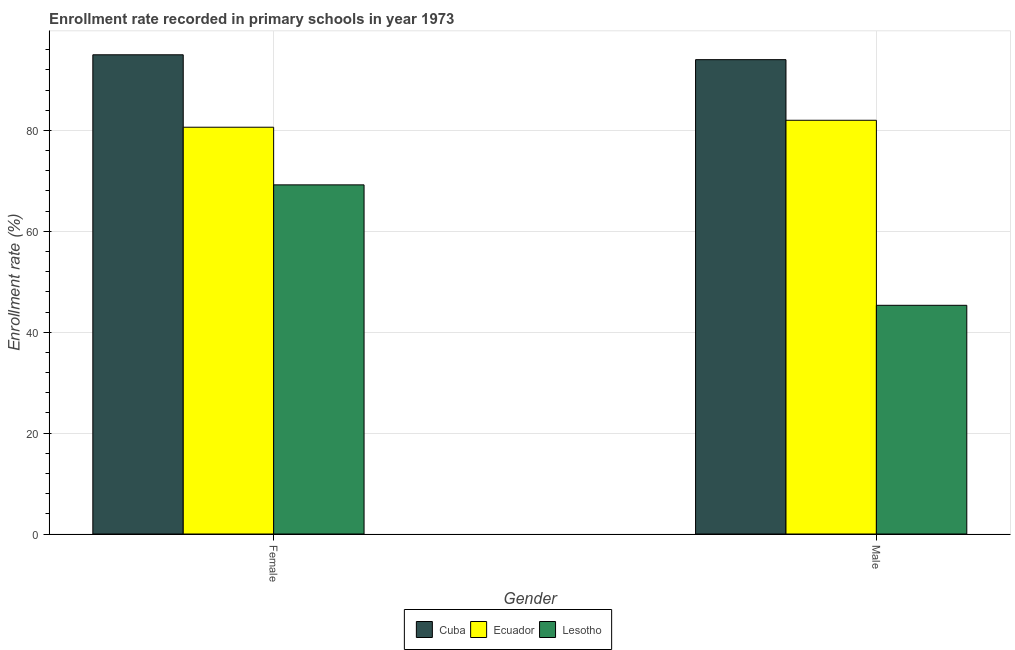How many different coloured bars are there?
Your answer should be very brief. 3. How many groups of bars are there?
Keep it short and to the point. 2. Are the number of bars per tick equal to the number of legend labels?
Give a very brief answer. Yes. Are the number of bars on each tick of the X-axis equal?
Make the answer very short. Yes. How many bars are there on the 1st tick from the left?
Provide a short and direct response. 3. How many bars are there on the 2nd tick from the right?
Give a very brief answer. 3. What is the label of the 1st group of bars from the left?
Keep it short and to the point. Female. What is the enrollment rate of female students in Cuba?
Give a very brief answer. 95. Across all countries, what is the maximum enrollment rate of male students?
Ensure brevity in your answer.  94.03. Across all countries, what is the minimum enrollment rate of female students?
Offer a very short reply. 69.21. In which country was the enrollment rate of female students maximum?
Your answer should be compact. Cuba. In which country was the enrollment rate of female students minimum?
Provide a short and direct response. Lesotho. What is the total enrollment rate of male students in the graph?
Your answer should be compact. 221.39. What is the difference between the enrollment rate of female students in Lesotho and that in Cuba?
Give a very brief answer. -25.79. What is the difference between the enrollment rate of female students in Cuba and the enrollment rate of male students in Lesotho?
Keep it short and to the point. 49.66. What is the average enrollment rate of male students per country?
Provide a short and direct response. 73.8. What is the difference between the enrollment rate of male students and enrollment rate of female students in Ecuador?
Make the answer very short. 1.38. What is the ratio of the enrollment rate of female students in Ecuador to that in Lesotho?
Offer a very short reply. 1.17. Is the enrollment rate of male students in Ecuador less than that in Lesotho?
Your answer should be very brief. No. In how many countries, is the enrollment rate of female students greater than the average enrollment rate of female students taken over all countries?
Keep it short and to the point. 1. What does the 2nd bar from the left in Male represents?
Offer a terse response. Ecuador. What does the 2nd bar from the right in Female represents?
Your response must be concise. Ecuador. What is the difference between two consecutive major ticks on the Y-axis?
Provide a succinct answer. 20. Does the graph contain grids?
Make the answer very short. Yes. Where does the legend appear in the graph?
Offer a terse response. Bottom center. How are the legend labels stacked?
Keep it short and to the point. Horizontal. What is the title of the graph?
Provide a succinct answer. Enrollment rate recorded in primary schools in year 1973. What is the label or title of the X-axis?
Your answer should be compact. Gender. What is the label or title of the Y-axis?
Make the answer very short. Enrollment rate (%). What is the Enrollment rate (%) in Cuba in Female?
Your response must be concise. 95. What is the Enrollment rate (%) in Ecuador in Female?
Provide a short and direct response. 80.64. What is the Enrollment rate (%) in Lesotho in Female?
Keep it short and to the point. 69.21. What is the Enrollment rate (%) in Cuba in Male?
Offer a terse response. 94.03. What is the Enrollment rate (%) of Ecuador in Male?
Your answer should be very brief. 82.02. What is the Enrollment rate (%) of Lesotho in Male?
Give a very brief answer. 45.34. Across all Gender, what is the maximum Enrollment rate (%) in Cuba?
Your answer should be compact. 95. Across all Gender, what is the maximum Enrollment rate (%) of Ecuador?
Keep it short and to the point. 82.02. Across all Gender, what is the maximum Enrollment rate (%) of Lesotho?
Give a very brief answer. 69.21. Across all Gender, what is the minimum Enrollment rate (%) in Cuba?
Your answer should be compact. 94.03. Across all Gender, what is the minimum Enrollment rate (%) in Ecuador?
Your answer should be compact. 80.64. Across all Gender, what is the minimum Enrollment rate (%) of Lesotho?
Offer a very short reply. 45.34. What is the total Enrollment rate (%) in Cuba in the graph?
Give a very brief answer. 189.03. What is the total Enrollment rate (%) of Ecuador in the graph?
Make the answer very short. 162.66. What is the total Enrollment rate (%) of Lesotho in the graph?
Your answer should be compact. 114.55. What is the difference between the Enrollment rate (%) of Cuba in Female and that in Male?
Your response must be concise. 0.97. What is the difference between the Enrollment rate (%) of Ecuador in Female and that in Male?
Offer a terse response. -1.38. What is the difference between the Enrollment rate (%) of Lesotho in Female and that in Male?
Provide a short and direct response. 23.87. What is the difference between the Enrollment rate (%) in Cuba in Female and the Enrollment rate (%) in Ecuador in Male?
Keep it short and to the point. 12.98. What is the difference between the Enrollment rate (%) in Cuba in Female and the Enrollment rate (%) in Lesotho in Male?
Provide a succinct answer. 49.66. What is the difference between the Enrollment rate (%) of Ecuador in Female and the Enrollment rate (%) of Lesotho in Male?
Make the answer very short. 35.3. What is the average Enrollment rate (%) in Cuba per Gender?
Your answer should be compact. 94.52. What is the average Enrollment rate (%) of Ecuador per Gender?
Provide a succinct answer. 81.33. What is the average Enrollment rate (%) of Lesotho per Gender?
Provide a short and direct response. 57.27. What is the difference between the Enrollment rate (%) in Cuba and Enrollment rate (%) in Ecuador in Female?
Give a very brief answer. 14.36. What is the difference between the Enrollment rate (%) in Cuba and Enrollment rate (%) in Lesotho in Female?
Offer a very short reply. 25.79. What is the difference between the Enrollment rate (%) of Ecuador and Enrollment rate (%) of Lesotho in Female?
Give a very brief answer. 11.43. What is the difference between the Enrollment rate (%) in Cuba and Enrollment rate (%) in Ecuador in Male?
Your response must be concise. 12.01. What is the difference between the Enrollment rate (%) of Cuba and Enrollment rate (%) of Lesotho in Male?
Ensure brevity in your answer.  48.69. What is the difference between the Enrollment rate (%) of Ecuador and Enrollment rate (%) of Lesotho in Male?
Offer a terse response. 36.68. What is the ratio of the Enrollment rate (%) of Cuba in Female to that in Male?
Provide a succinct answer. 1.01. What is the ratio of the Enrollment rate (%) of Ecuador in Female to that in Male?
Provide a succinct answer. 0.98. What is the ratio of the Enrollment rate (%) of Lesotho in Female to that in Male?
Your response must be concise. 1.53. What is the difference between the highest and the second highest Enrollment rate (%) of Cuba?
Your answer should be compact. 0.97. What is the difference between the highest and the second highest Enrollment rate (%) in Ecuador?
Your response must be concise. 1.38. What is the difference between the highest and the second highest Enrollment rate (%) in Lesotho?
Your response must be concise. 23.87. What is the difference between the highest and the lowest Enrollment rate (%) in Cuba?
Give a very brief answer. 0.97. What is the difference between the highest and the lowest Enrollment rate (%) in Ecuador?
Your response must be concise. 1.38. What is the difference between the highest and the lowest Enrollment rate (%) of Lesotho?
Your answer should be compact. 23.87. 